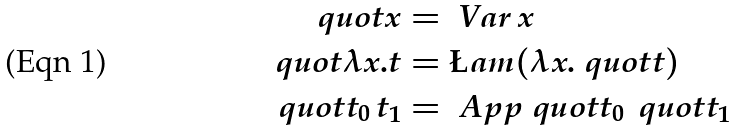<formula> <loc_0><loc_0><loc_500><loc_500>\ q u o t { x } & = \ V a r \, x \\ \ q u o t { \lambda x . t } & = \L a m ( \lambda x . \ q u o t t ) \\ \ q u o t { t _ { 0 } \, t _ { 1 } } & = \ A p p \ q u o t { t _ { 0 } } \, \ q u o t { t _ { 1 } }</formula> 